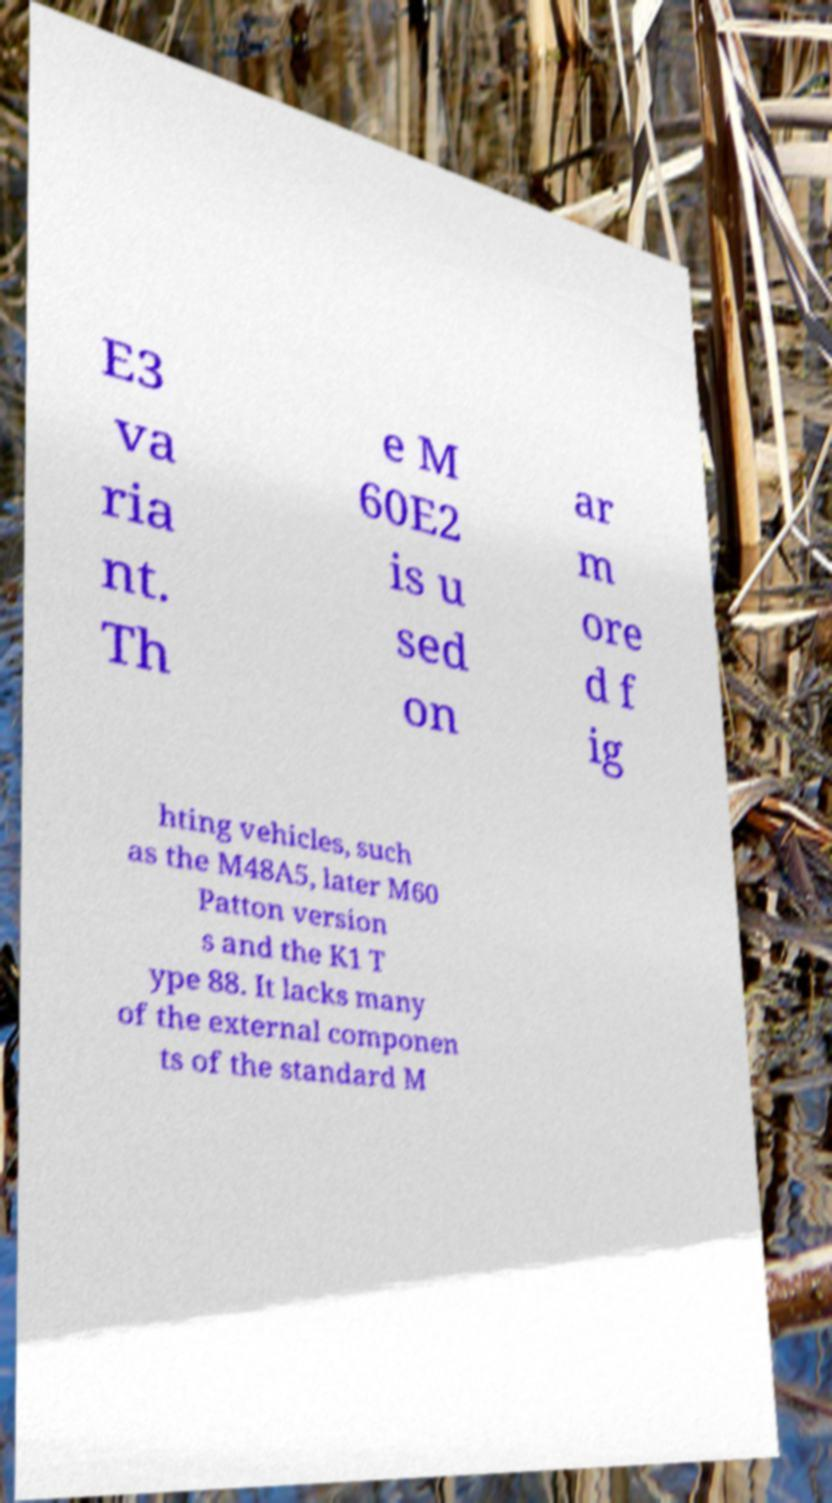Can you read and provide the text displayed in the image?This photo seems to have some interesting text. Can you extract and type it out for me? E3 va ria nt. Th e M 60E2 is u sed on ar m ore d f ig hting vehicles, such as the M48A5, later M60 Patton version s and the K1 T ype 88. It lacks many of the external componen ts of the standard M 